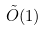Convert formula to latex. <formula><loc_0><loc_0><loc_500><loc_500>\tilde { O } ( 1 )</formula> 